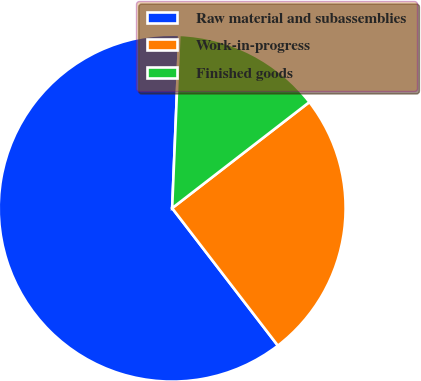Convert chart to OTSL. <chart><loc_0><loc_0><loc_500><loc_500><pie_chart><fcel>Raw material and subassemblies<fcel>Work-in-progress<fcel>Finished goods<nl><fcel>61.09%<fcel>25.04%<fcel>13.87%<nl></chart> 